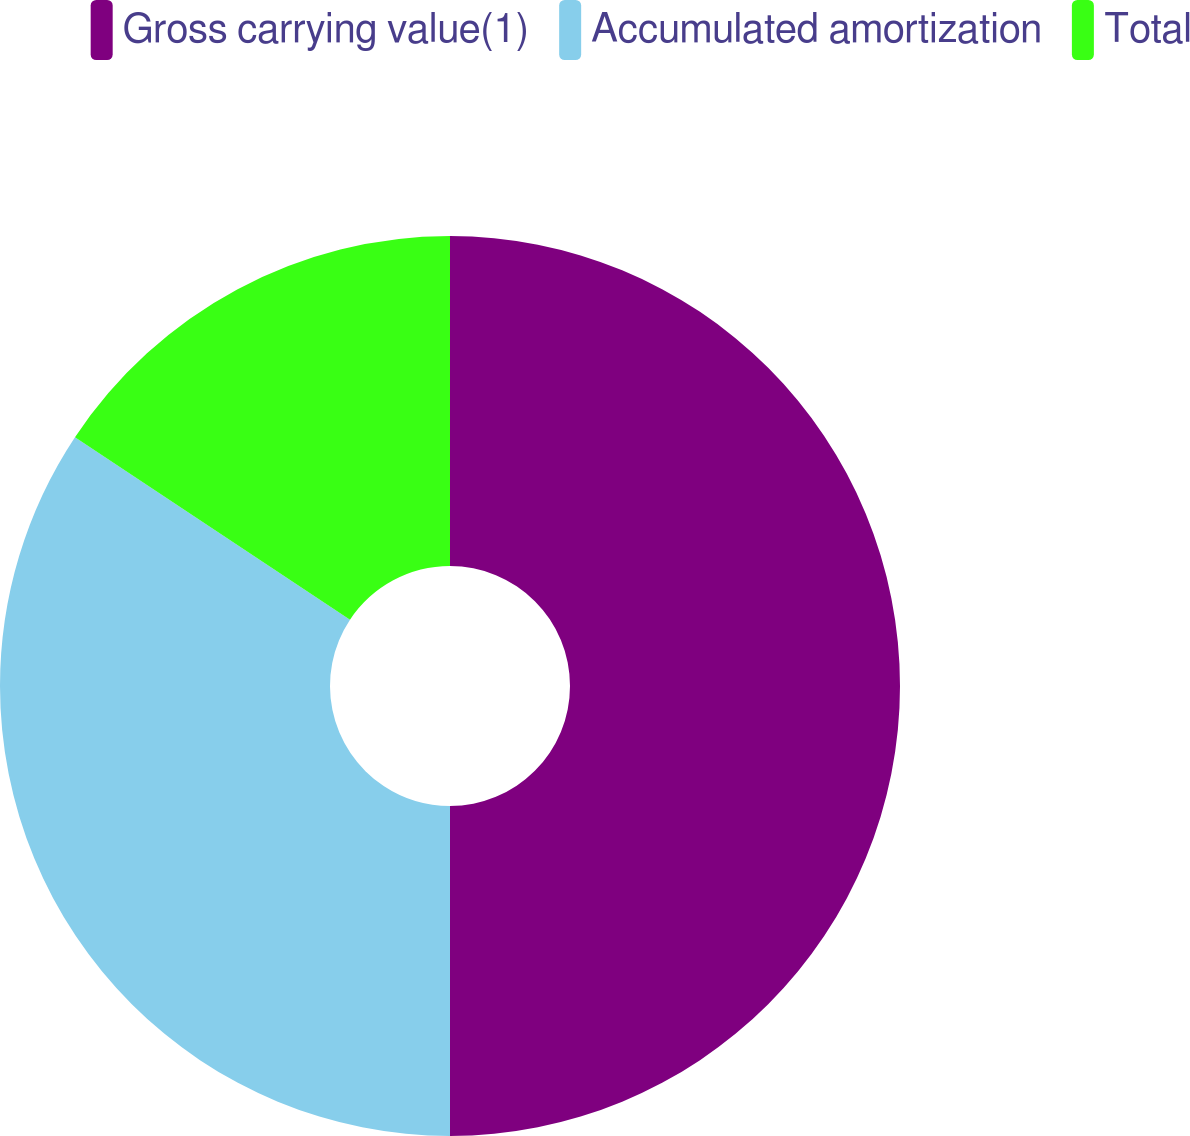Convert chart. <chart><loc_0><loc_0><loc_500><loc_500><pie_chart><fcel>Gross carrying value(1)<fcel>Accumulated amortization<fcel>Total<nl><fcel>50.0%<fcel>34.32%<fcel>15.68%<nl></chart> 